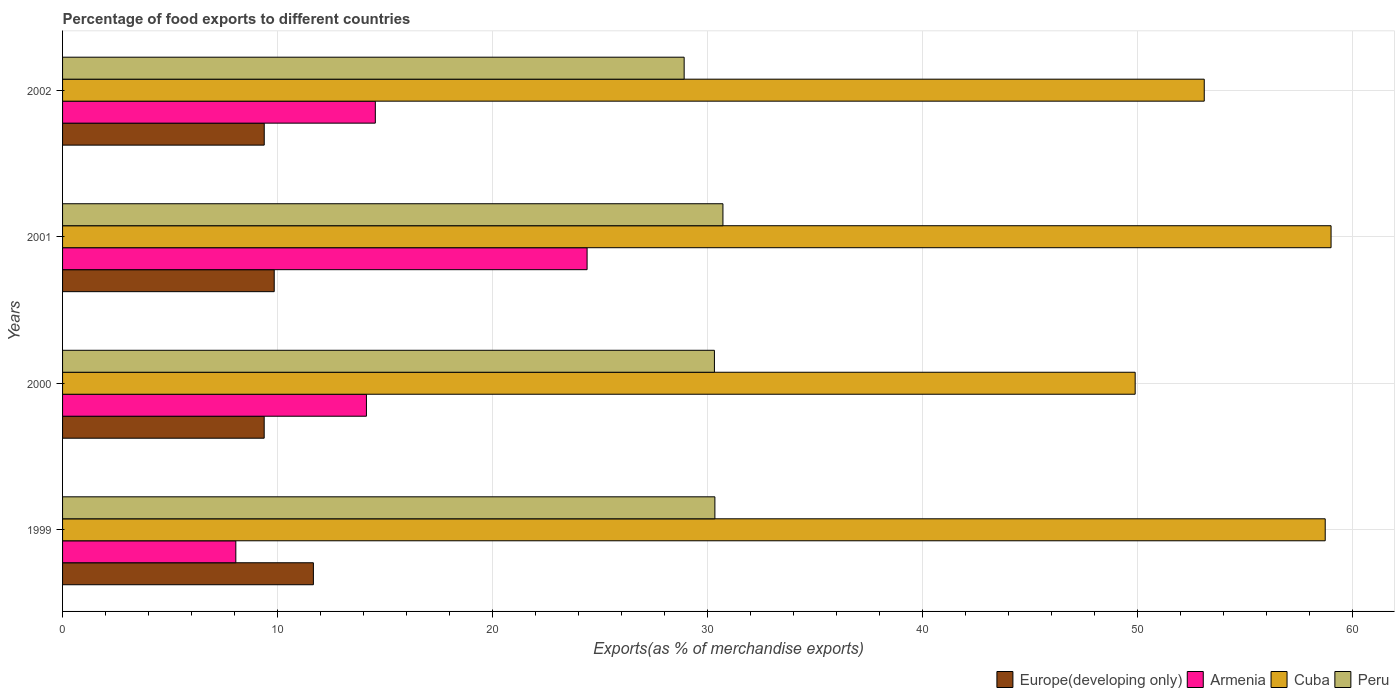How many bars are there on the 3rd tick from the bottom?
Offer a terse response. 4. What is the label of the 3rd group of bars from the top?
Provide a short and direct response. 2000. In how many cases, is the number of bars for a given year not equal to the number of legend labels?
Provide a succinct answer. 0. What is the percentage of exports to different countries in Cuba in 2002?
Ensure brevity in your answer.  53.12. Across all years, what is the maximum percentage of exports to different countries in Europe(developing only)?
Provide a succinct answer. 11.67. Across all years, what is the minimum percentage of exports to different countries in Peru?
Provide a short and direct response. 28.92. In which year was the percentage of exports to different countries in Armenia maximum?
Your answer should be very brief. 2001. What is the total percentage of exports to different countries in Armenia in the graph?
Make the answer very short. 61.15. What is the difference between the percentage of exports to different countries in Peru in 2000 and that in 2002?
Offer a very short reply. 1.41. What is the difference between the percentage of exports to different countries in Armenia in 2001 and the percentage of exports to different countries in Cuba in 2002?
Ensure brevity in your answer.  -28.71. What is the average percentage of exports to different countries in Cuba per year?
Your response must be concise. 55.19. In the year 2001, what is the difference between the percentage of exports to different countries in Peru and percentage of exports to different countries in Armenia?
Offer a terse response. 6.32. What is the ratio of the percentage of exports to different countries in Armenia in 1999 to that in 2001?
Your answer should be very brief. 0.33. Is the percentage of exports to different countries in Armenia in 1999 less than that in 2001?
Offer a terse response. Yes. Is the difference between the percentage of exports to different countries in Peru in 1999 and 2000 greater than the difference between the percentage of exports to different countries in Armenia in 1999 and 2000?
Keep it short and to the point. Yes. What is the difference between the highest and the second highest percentage of exports to different countries in Peru?
Offer a terse response. 0.37. What is the difference between the highest and the lowest percentage of exports to different countries in Europe(developing only)?
Provide a short and direct response. 2.29. Is the sum of the percentage of exports to different countries in Armenia in 2001 and 2002 greater than the maximum percentage of exports to different countries in Cuba across all years?
Your answer should be compact. No. What does the 2nd bar from the top in 2001 represents?
Provide a succinct answer. Cuba. How many bars are there?
Keep it short and to the point. 16. How many years are there in the graph?
Make the answer very short. 4. What is the difference between two consecutive major ticks on the X-axis?
Offer a terse response. 10. Does the graph contain any zero values?
Offer a terse response. No. Does the graph contain grids?
Offer a terse response. Yes. What is the title of the graph?
Provide a short and direct response. Percentage of food exports to different countries. What is the label or title of the X-axis?
Offer a terse response. Exports(as % of merchandise exports). What is the label or title of the Y-axis?
Your answer should be compact. Years. What is the Exports(as % of merchandise exports) of Europe(developing only) in 1999?
Your response must be concise. 11.67. What is the Exports(as % of merchandise exports) in Armenia in 1999?
Your answer should be very brief. 8.06. What is the Exports(as % of merchandise exports) of Cuba in 1999?
Provide a succinct answer. 58.74. What is the Exports(as % of merchandise exports) in Peru in 1999?
Offer a very short reply. 30.35. What is the Exports(as % of merchandise exports) of Europe(developing only) in 2000?
Your answer should be compact. 9.38. What is the Exports(as % of merchandise exports) of Armenia in 2000?
Provide a succinct answer. 14.14. What is the Exports(as % of merchandise exports) of Cuba in 2000?
Make the answer very short. 49.9. What is the Exports(as % of merchandise exports) of Peru in 2000?
Keep it short and to the point. 30.33. What is the Exports(as % of merchandise exports) in Europe(developing only) in 2001?
Offer a very short reply. 9.85. What is the Exports(as % of merchandise exports) of Armenia in 2001?
Your response must be concise. 24.4. What is the Exports(as % of merchandise exports) of Cuba in 2001?
Give a very brief answer. 59.02. What is the Exports(as % of merchandise exports) in Peru in 2001?
Provide a short and direct response. 30.72. What is the Exports(as % of merchandise exports) in Europe(developing only) in 2002?
Your response must be concise. 9.38. What is the Exports(as % of merchandise exports) of Armenia in 2002?
Keep it short and to the point. 14.55. What is the Exports(as % of merchandise exports) in Cuba in 2002?
Give a very brief answer. 53.12. What is the Exports(as % of merchandise exports) of Peru in 2002?
Make the answer very short. 28.92. Across all years, what is the maximum Exports(as % of merchandise exports) in Europe(developing only)?
Keep it short and to the point. 11.67. Across all years, what is the maximum Exports(as % of merchandise exports) in Armenia?
Give a very brief answer. 24.4. Across all years, what is the maximum Exports(as % of merchandise exports) of Cuba?
Offer a terse response. 59.02. Across all years, what is the maximum Exports(as % of merchandise exports) in Peru?
Your answer should be compact. 30.72. Across all years, what is the minimum Exports(as % of merchandise exports) of Europe(developing only)?
Offer a terse response. 9.38. Across all years, what is the minimum Exports(as % of merchandise exports) of Armenia?
Make the answer very short. 8.06. Across all years, what is the minimum Exports(as % of merchandise exports) in Cuba?
Provide a succinct answer. 49.9. Across all years, what is the minimum Exports(as % of merchandise exports) of Peru?
Offer a terse response. 28.92. What is the total Exports(as % of merchandise exports) of Europe(developing only) in the graph?
Your response must be concise. 40.28. What is the total Exports(as % of merchandise exports) of Armenia in the graph?
Provide a succinct answer. 61.15. What is the total Exports(as % of merchandise exports) in Cuba in the graph?
Keep it short and to the point. 220.78. What is the total Exports(as % of merchandise exports) of Peru in the graph?
Offer a terse response. 120.32. What is the difference between the Exports(as % of merchandise exports) of Europe(developing only) in 1999 and that in 2000?
Your response must be concise. 2.29. What is the difference between the Exports(as % of merchandise exports) in Armenia in 1999 and that in 2000?
Ensure brevity in your answer.  -6.08. What is the difference between the Exports(as % of merchandise exports) of Cuba in 1999 and that in 2000?
Your answer should be compact. 8.84. What is the difference between the Exports(as % of merchandise exports) in Peru in 1999 and that in 2000?
Your answer should be compact. 0.02. What is the difference between the Exports(as % of merchandise exports) in Europe(developing only) in 1999 and that in 2001?
Offer a very short reply. 1.82. What is the difference between the Exports(as % of merchandise exports) in Armenia in 1999 and that in 2001?
Your answer should be very brief. -16.34. What is the difference between the Exports(as % of merchandise exports) of Cuba in 1999 and that in 2001?
Provide a succinct answer. -0.27. What is the difference between the Exports(as % of merchandise exports) of Peru in 1999 and that in 2001?
Your answer should be compact. -0.37. What is the difference between the Exports(as % of merchandise exports) in Europe(developing only) in 1999 and that in 2002?
Ensure brevity in your answer.  2.29. What is the difference between the Exports(as % of merchandise exports) of Armenia in 1999 and that in 2002?
Offer a terse response. -6.49. What is the difference between the Exports(as % of merchandise exports) in Cuba in 1999 and that in 2002?
Make the answer very short. 5.63. What is the difference between the Exports(as % of merchandise exports) of Peru in 1999 and that in 2002?
Ensure brevity in your answer.  1.43. What is the difference between the Exports(as % of merchandise exports) of Europe(developing only) in 2000 and that in 2001?
Offer a terse response. -0.47. What is the difference between the Exports(as % of merchandise exports) in Armenia in 2000 and that in 2001?
Your response must be concise. -10.27. What is the difference between the Exports(as % of merchandise exports) in Cuba in 2000 and that in 2001?
Give a very brief answer. -9.11. What is the difference between the Exports(as % of merchandise exports) of Peru in 2000 and that in 2001?
Your answer should be compact. -0.4. What is the difference between the Exports(as % of merchandise exports) in Europe(developing only) in 2000 and that in 2002?
Make the answer very short. -0. What is the difference between the Exports(as % of merchandise exports) in Armenia in 2000 and that in 2002?
Keep it short and to the point. -0.41. What is the difference between the Exports(as % of merchandise exports) in Cuba in 2000 and that in 2002?
Keep it short and to the point. -3.21. What is the difference between the Exports(as % of merchandise exports) of Peru in 2000 and that in 2002?
Your answer should be very brief. 1.41. What is the difference between the Exports(as % of merchandise exports) of Europe(developing only) in 2001 and that in 2002?
Provide a succinct answer. 0.46. What is the difference between the Exports(as % of merchandise exports) in Armenia in 2001 and that in 2002?
Your answer should be very brief. 9.85. What is the difference between the Exports(as % of merchandise exports) of Cuba in 2001 and that in 2002?
Provide a succinct answer. 5.9. What is the difference between the Exports(as % of merchandise exports) of Peru in 2001 and that in 2002?
Your answer should be very brief. 1.8. What is the difference between the Exports(as % of merchandise exports) in Europe(developing only) in 1999 and the Exports(as % of merchandise exports) in Armenia in 2000?
Keep it short and to the point. -2.47. What is the difference between the Exports(as % of merchandise exports) of Europe(developing only) in 1999 and the Exports(as % of merchandise exports) of Cuba in 2000?
Provide a short and direct response. -38.23. What is the difference between the Exports(as % of merchandise exports) in Europe(developing only) in 1999 and the Exports(as % of merchandise exports) in Peru in 2000?
Offer a very short reply. -18.66. What is the difference between the Exports(as % of merchandise exports) of Armenia in 1999 and the Exports(as % of merchandise exports) of Cuba in 2000?
Provide a short and direct response. -41.84. What is the difference between the Exports(as % of merchandise exports) in Armenia in 1999 and the Exports(as % of merchandise exports) in Peru in 2000?
Your response must be concise. -22.27. What is the difference between the Exports(as % of merchandise exports) in Cuba in 1999 and the Exports(as % of merchandise exports) in Peru in 2000?
Give a very brief answer. 28.42. What is the difference between the Exports(as % of merchandise exports) in Europe(developing only) in 1999 and the Exports(as % of merchandise exports) in Armenia in 2001?
Provide a short and direct response. -12.73. What is the difference between the Exports(as % of merchandise exports) in Europe(developing only) in 1999 and the Exports(as % of merchandise exports) in Cuba in 2001?
Your response must be concise. -47.35. What is the difference between the Exports(as % of merchandise exports) of Europe(developing only) in 1999 and the Exports(as % of merchandise exports) of Peru in 2001?
Make the answer very short. -19.05. What is the difference between the Exports(as % of merchandise exports) in Armenia in 1999 and the Exports(as % of merchandise exports) in Cuba in 2001?
Your answer should be compact. -50.96. What is the difference between the Exports(as % of merchandise exports) of Armenia in 1999 and the Exports(as % of merchandise exports) of Peru in 2001?
Offer a very short reply. -22.66. What is the difference between the Exports(as % of merchandise exports) of Cuba in 1999 and the Exports(as % of merchandise exports) of Peru in 2001?
Ensure brevity in your answer.  28.02. What is the difference between the Exports(as % of merchandise exports) of Europe(developing only) in 1999 and the Exports(as % of merchandise exports) of Armenia in 2002?
Keep it short and to the point. -2.88. What is the difference between the Exports(as % of merchandise exports) in Europe(developing only) in 1999 and the Exports(as % of merchandise exports) in Cuba in 2002?
Your answer should be very brief. -41.45. What is the difference between the Exports(as % of merchandise exports) in Europe(developing only) in 1999 and the Exports(as % of merchandise exports) in Peru in 2002?
Offer a very short reply. -17.25. What is the difference between the Exports(as % of merchandise exports) in Armenia in 1999 and the Exports(as % of merchandise exports) in Cuba in 2002?
Offer a very short reply. -45.06. What is the difference between the Exports(as % of merchandise exports) of Armenia in 1999 and the Exports(as % of merchandise exports) of Peru in 2002?
Your answer should be compact. -20.86. What is the difference between the Exports(as % of merchandise exports) of Cuba in 1999 and the Exports(as % of merchandise exports) of Peru in 2002?
Make the answer very short. 29.83. What is the difference between the Exports(as % of merchandise exports) of Europe(developing only) in 2000 and the Exports(as % of merchandise exports) of Armenia in 2001?
Provide a short and direct response. -15.02. What is the difference between the Exports(as % of merchandise exports) in Europe(developing only) in 2000 and the Exports(as % of merchandise exports) in Cuba in 2001?
Your answer should be compact. -49.64. What is the difference between the Exports(as % of merchandise exports) in Europe(developing only) in 2000 and the Exports(as % of merchandise exports) in Peru in 2001?
Make the answer very short. -21.34. What is the difference between the Exports(as % of merchandise exports) of Armenia in 2000 and the Exports(as % of merchandise exports) of Cuba in 2001?
Offer a very short reply. -44.88. What is the difference between the Exports(as % of merchandise exports) in Armenia in 2000 and the Exports(as % of merchandise exports) in Peru in 2001?
Provide a succinct answer. -16.59. What is the difference between the Exports(as % of merchandise exports) in Cuba in 2000 and the Exports(as % of merchandise exports) in Peru in 2001?
Your response must be concise. 19.18. What is the difference between the Exports(as % of merchandise exports) in Europe(developing only) in 2000 and the Exports(as % of merchandise exports) in Armenia in 2002?
Offer a terse response. -5.17. What is the difference between the Exports(as % of merchandise exports) in Europe(developing only) in 2000 and the Exports(as % of merchandise exports) in Cuba in 2002?
Ensure brevity in your answer.  -43.74. What is the difference between the Exports(as % of merchandise exports) in Europe(developing only) in 2000 and the Exports(as % of merchandise exports) in Peru in 2002?
Ensure brevity in your answer.  -19.54. What is the difference between the Exports(as % of merchandise exports) of Armenia in 2000 and the Exports(as % of merchandise exports) of Cuba in 2002?
Give a very brief answer. -38.98. What is the difference between the Exports(as % of merchandise exports) of Armenia in 2000 and the Exports(as % of merchandise exports) of Peru in 2002?
Your answer should be very brief. -14.78. What is the difference between the Exports(as % of merchandise exports) in Cuba in 2000 and the Exports(as % of merchandise exports) in Peru in 2002?
Your response must be concise. 20.98. What is the difference between the Exports(as % of merchandise exports) in Europe(developing only) in 2001 and the Exports(as % of merchandise exports) in Armenia in 2002?
Offer a terse response. -4.7. What is the difference between the Exports(as % of merchandise exports) in Europe(developing only) in 2001 and the Exports(as % of merchandise exports) in Cuba in 2002?
Your response must be concise. -43.27. What is the difference between the Exports(as % of merchandise exports) of Europe(developing only) in 2001 and the Exports(as % of merchandise exports) of Peru in 2002?
Your answer should be very brief. -19.07. What is the difference between the Exports(as % of merchandise exports) in Armenia in 2001 and the Exports(as % of merchandise exports) in Cuba in 2002?
Keep it short and to the point. -28.71. What is the difference between the Exports(as % of merchandise exports) of Armenia in 2001 and the Exports(as % of merchandise exports) of Peru in 2002?
Offer a terse response. -4.52. What is the difference between the Exports(as % of merchandise exports) in Cuba in 2001 and the Exports(as % of merchandise exports) in Peru in 2002?
Make the answer very short. 30.1. What is the average Exports(as % of merchandise exports) in Europe(developing only) per year?
Your answer should be compact. 10.07. What is the average Exports(as % of merchandise exports) of Armenia per year?
Provide a succinct answer. 15.29. What is the average Exports(as % of merchandise exports) of Cuba per year?
Provide a short and direct response. 55.19. What is the average Exports(as % of merchandise exports) in Peru per year?
Your response must be concise. 30.08. In the year 1999, what is the difference between the Exports(as % of merchandise exports) in Europe(developing only) and Exports(as % of merchandise exports) in Armenia?
Your response must be concise. 3.61. In the year 1999, what is the difference between the Exports(as % of merchandise exports) in Europe(developing only) and Exports(as % of merchandise exports) in Cuba?
Keep it short and to the point. -47.07. In the year 1999, what is the difference between the Exports(as % of merchandise exports) of Europe(developing only) and Exports(as % of merchandise exports) of Peru?
Offer a terse response. -18.68. In the year 1999, what is the difference between the Exports(as % of merchandise exports) in Armenia and Exports(as % of merchandise exports) in Cuba?
Your answer should be compact. -50.68. In the year 1999, what is the difference between the Exports(as % of merchandise exports) of Armenia and Exports(as % of merchandise exports) of Peru?
Give a very brief answer. -22.29. In the year 1999, what is the difference between the Exports(as % of merchandise exports) of Cuba and Exports(as % of merchandise exports) of Peru?
Your answer should be very brief. 28.39. In the year 2000, what is the difference between the Exports(as % of merchandise exports) in Europe(developing only) and Exports(as % of merchandise exports) in Armenia?
Offer a terse response. -4.76. In the year 2000, what is the difference between the Exports(as % of merchandise exports) in Europe(developing only) and Exports(as % of merchandise exports) in Cuba?
Offer a very short reply. -40.52. In the year 2000, what is the difference between the Exports(as % of merchandise exports) in Europe(developing only) and Exports(as % of merchandise exports) in Peru?
Your answer should be compact. -20.95. In the year 2000, what is the difference between the Exports(as % of merchandise exports) in Armenia and Exports(as % of merchandise exports) in Cuba?
Your response must be concise. -35.76. In the year 2000, what is the difference between the Exports(as % of merchandise exports) of Armenia and Exports(as % of merchandise exports) of Peru?
Give a very brief answer. -16.19. In the year 2000, what is the difference between the Exports(as % of merchandise exports) in Cuba and Exports(as % of merchandise exports) in Peru?
Keep it short and to the point. 19.57. In the year 2001, what is the difference between the Exports(as % of merchandise exports) of Europe(developing only) and Exports(as % of merchandise exports) of Armenia?
Give a very brief answer. -14.56. In the year 2001, what is the difference between the Exports(as % of merchandise exports) of Europe(developing only) and Exports(as % of merchandise exports) of Cuba?
Your answer should be compact. -49.17. In the year 2001, what is the difference between the Exports(as % of merchandise exports) in Europe(developing only) and Exports(as % of merchandise exports) in Peru?
Provide a short and direct response. -20.88. In the year 2001, what is the difference between the Exports(as % of merchandise exports) in Armenia and Exports(as % of merchandise exports) in Cuba?
Make the answer very short. -34.61. In the year 2001, what is the difference between the Exports(as % of merchandise exports) in Armenia and Exports(as % of merchandise exports) in Peru?
Your response must be concise. -6.32. In the year 2001, what is the difference between the Exports(as % of merchandise exports) in Cuba and Exports(as % of merchandise exports) in Peru?
Your response must be concise. 28.29. In the year 2002, what is the difference between the Exports(as % of merchandise exports) of Europe(developing only) and Exports(as % of merchandise exports) of Armenia?
Your response must be concise. -5.17. In the year 2002, what is the difference between the Exports(as % of merchandise exports) in Europe(developing only) and Exports(as % of merchandise exports) in Cuba?
Offer a very short reply. -43.73. In the year 2002, what is the difference between the Exports(as % of merchandise exports) of Europe(developing only) and Exports(as % of merchandise exports) of Peru?
Provide a succinct answer. -19.54. In the year 2002, what is the difference between the Exports(as % of merchandise exports) of Armenia and Exports(as % of merchandise exports) of Cuba?
Your answer should be very brief. -38.57. In the year 2002, what is the difference between the Exports(as % of merchandise exports) in Armenia and Exports(as % of merchandise exports) in Peru?
Provide a succinct answer. -14.37. In the year 2002, what is the difference between the Exports(as % of merchandise exports) in Cuba and Exports(as % of merchandise exports) in Peru?
Keep it short and to the point. 24.2. What is the ratio of the Exports(as % of merchandise exports) of Europe(developing only) in 1999 to that in 2000?
Offer a very short reply. 1.24. What is the ratio of the Exports(as % of merchandise exports) in Armenia in 1999 to that in 2000?
Your response must be concise. 0.57. What is the ratio of the Exports(as % of merchandise exports) in Cuba in 1999 to that in 2000?
Offer a very short reply. 1.18. What is the ratio of the Exports(as % of merchandise exports) of Europe(developing only) in 1999 to that in 2001?
Offer a very short reply. 1.19. What is the ratio of the Exports(as % of merchandise exports) of Armenia in 1999 to that in 2001?
Offer a terse response. 0.33. What is the ratio of the Exports(as % of merchandise exports) in Cuba in 1999 to that in 2001?
Make the answer very short. 1. What is the ratio of the Exports(as % of merchandise exports) of Peru in 1999 to that in 2001?
Give a very brief answer. 0.99. What is the ratio of the Exports(as % of merchandise exports) in Europe(developing only) in 1999 to that in 2002?
Provide a succinct answer. 1.24. What is the ratio of the Exports(as % of merchandise exports) in Armenia in 1999 to that in 2002?
Provide a short and direct response. 0.55. What is the ratio of the Exports(as % of merchandise exports) in Cuba in 1999 to that in 2002?
Offer a very short reply. 1.11. What is the ratio of the Exports(as % of merchandise exports) of Peru in 1999 to that in 2002?
Offer a terse response. 1.05. What is the ratio of the Exports(as % of merchandise exports) of Europe(developing only) in 2000 to that in 2001?
Provide a short and direct response. 0.95. What is the ratio of the Exports(as % of merchandise exports) of Armenia in 2000 to that in 2001?
Offer a terse response. 0.58. What is the ratio of the Exports(as % of merchandise exports) of Cuba in 2000 to that in 2001?
Ensure brevity in your answer.  0.85. What is the ratio of the Exports(as % of merchandise exports) of Peru in 2000 to that in 2001?
Ensure brevity in your answer.  0.99. What is the ratio of the Exports(as % of merchandise exports) in Armenia in 2000 to that in 2002?
Provide a short and direct response. 0.97. What is the ratio of the Exports(as % of merchandise exports) of Cuba in 2000 to that in 2002?
Your response must be concise. 0.94. What is the ratio of the Exports(as % of merchandise exports) of Peru in 2000 to that in 2002?
Offer a terse response. 1.05. What is the ratio of the Exports(as % of merchandise exports) in Europe(developing only) in 2001 to that in 2002?
Give a very brief answer. 1.05. What is the ratio of the Exports(as % of merchandise exports) of Armenia in 2001 to that in 2002?
Provide a short and direct response. 1.68. What is the ratio of the Exports(as % of merchandise exports) in Cuba in 2001 to that in 2002?
Your answer should be compact. 1.11. What is the ratio of the Exports(as % of merchandise exports) in Peru in 2001 to that in 2002?
Your response must be concise. 1.06. What is the difference between the highest and the second highest Exports(as % of merchandise exports) in Europe(developing only)?
Ensure brevity in your answer.  1.82. What is the difference between the highest and the second highest Exports(as % of merchandise exports) of Armenia?
Your answer should be compact. 9.85. What is the difference between the highest and the second highest Exports(as % of merchandise exports) in Cuba?
Offer a very short reply. 0.27. What is the difference between the highest and the second highest Exports(as % of merchandise exports) of Peru?
Offer a very short reply. 0.37. What is the difference between the highest and the lowest Exports(as % of merchandise exports) of Europe(developing only)?
Give a very brief answer. 2.29. What is the difference between the highest and the lowest Exports(as % of merchandise exports) of Armenia?
Your answer should be compact. 16.34. What is the difference between the highest and the lowest Exports(as % of merchandise exports) in Cuba?
Your answer should be very brief. 9.11. What is the difference between the highest and the lowest Exports(as % of merchandise exports) of Peru?
Your answer should be very brief. 1.8. 